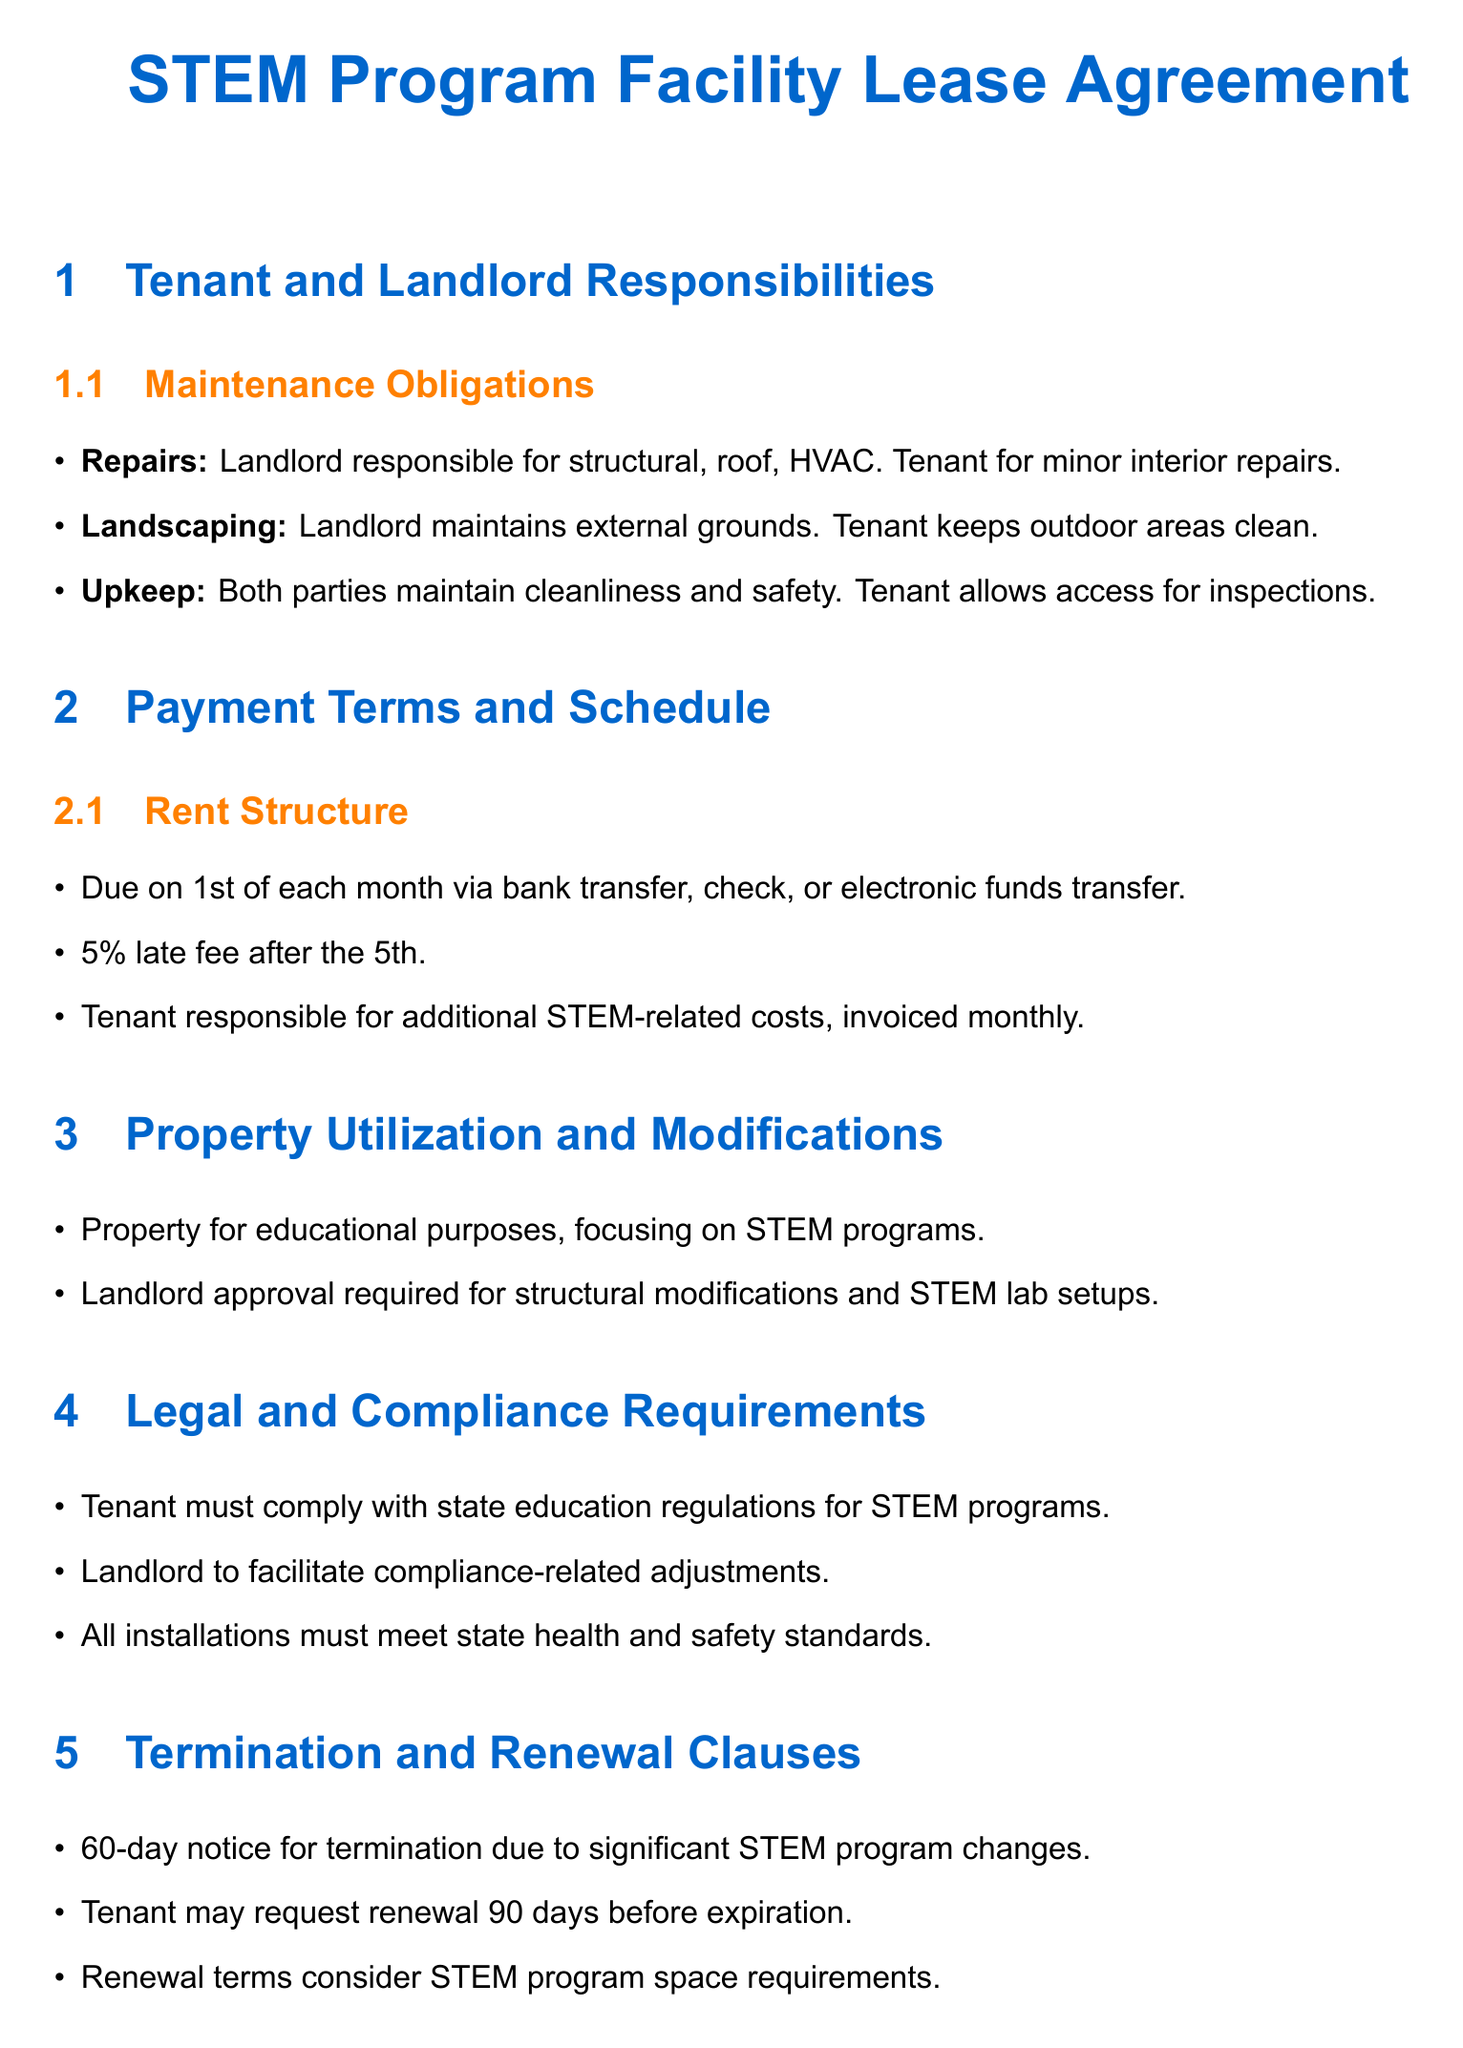What is the rent due date? The document specifies that rent is due on the 1st of each month.
Answer: 1st of each month Who is responsible for structural repairs? The landlord is responsible for structural repairs as outlined in the maintenance obligations.
Answer: Landlord What is the late fee percentage? The document states that there is a 5% late fee applied after the 5th of the month.
Answer: 5% What notice period is required for termination? The lease agreement requires a 60-day notice for termination if there are significant changes in the STEM program.
Answer: 60-day What must the tenant comply with regarding STEM programs? The tenant must comply with state education regulations related to STEM programs as mentioned under legal requirements.
Answer: State education regulations How far in advance can the tenant request renewal? The tenant may request renewal 90 days before the lease expiration.
Answer: 90 days Who maintains the external grounds? The landlord is responsible for maintaining the external grounds as per the maintenance obligations.
Answer: Landlord What is required for structural modifications? Landlord approval is required for any structural modifications related to the STEM lab setups.
Answer: Landlord approval 